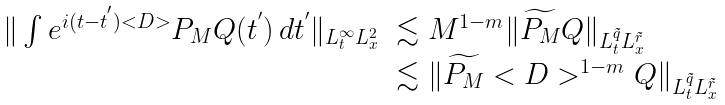<formula> <loc_0><loc_0><loc_500><loc_500>\begin{array} { l l } \| \int e ^ { i ( t - t ^ { ^ { \prime } } ) < D > } P _ { M } Q ( t ^ { ^ { \prime } } ) \, d t ^ { ^ { \prime } } \| _ { L _ { t } ^ { \infty } L _ { x } ^ { 2 } } & \lesssim M ^ { 1 - m } \| \widetilde { P _ { M } } Q \| _ { L _ { t } ^ { \tilde { q } } L _ { x } ^ { \tilde { r } } } \\ & \lesssim \| \widetilde { P _ { M } } < D > ^ { 1 - m } Q \| _ { L _ { t } ^ { \tilde { q } } L _ { x } ^ { \tilde { r } } } \end{array}</formula> 